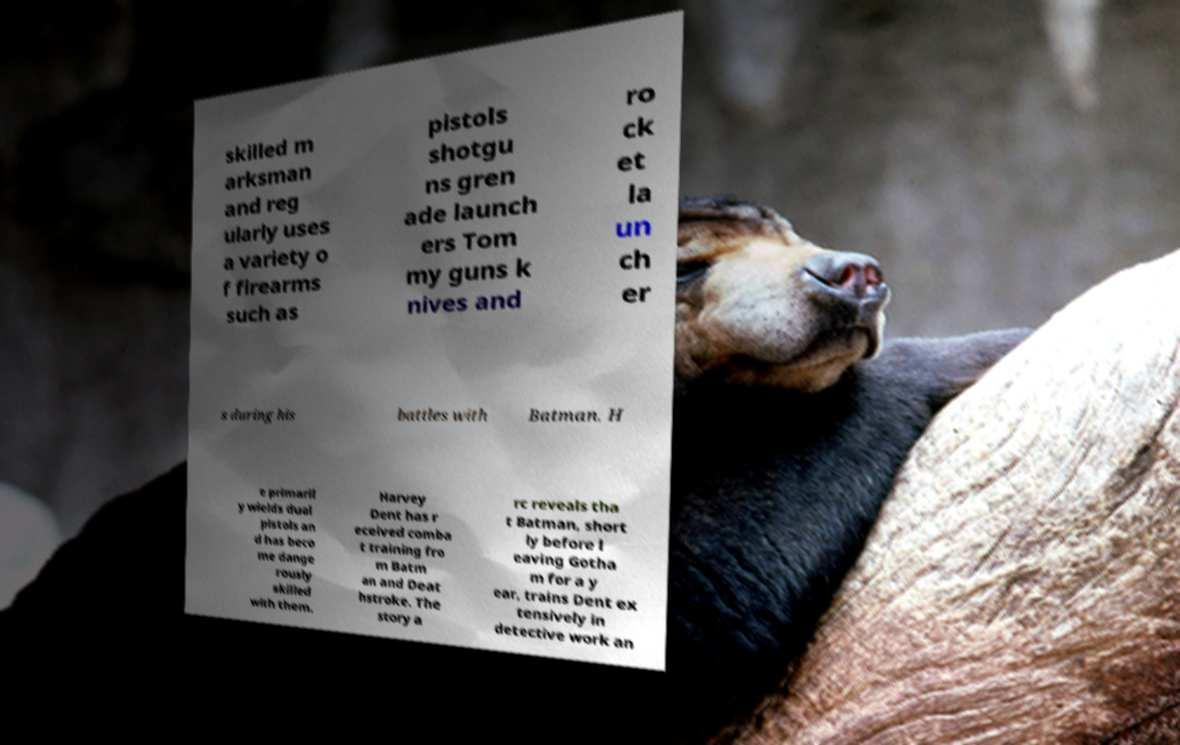Can you accurately transcribe the text from the provided image for me? skilled m arksman and reg ularly uses a variety o f firearms such as pistols shotgu ns gren ade launch ers Tom my guns k nives and ro ck et la un ch er s during his battles with Batman. H e primaril y wields dual pistols an d has beco me dange rously skilled with them. Harvey Dent has r eceived comba t training fro m Batm an and Deat hstroke. The story a rc reveals tha t Batman, short ly before l eaving Gotha m for a y ear, trains Dent ex tensively in detective work an 